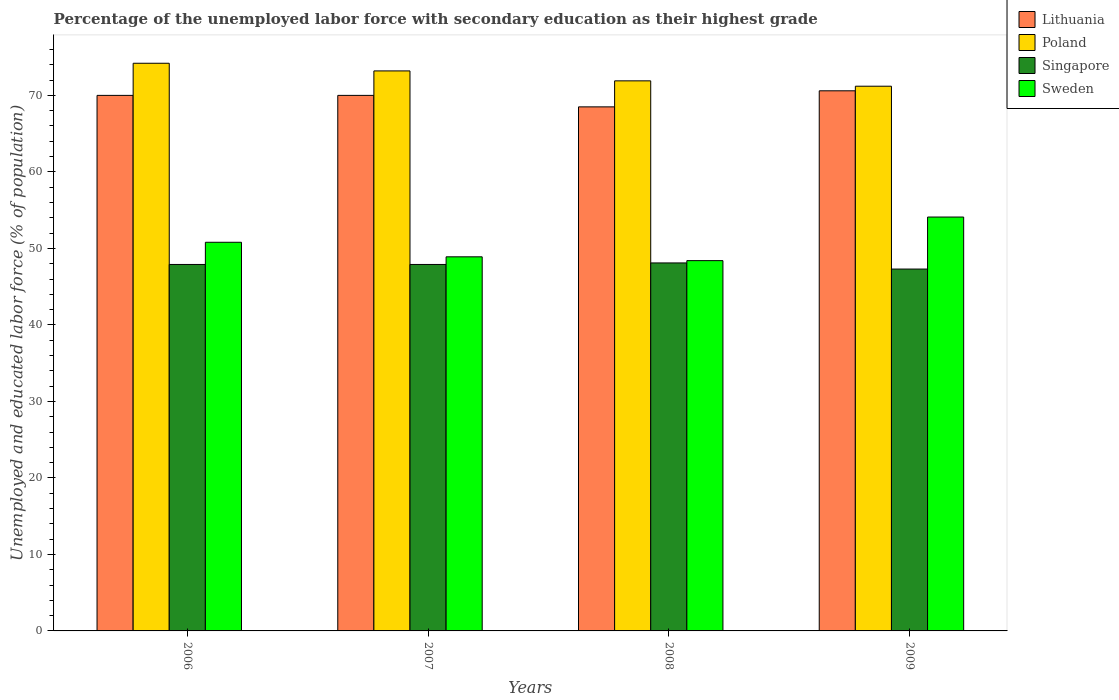Are the number of bars per tick equal to the number of legend labels?
Give a very brief answer. Yes. How many bars are there on the 2nd tick from the left?
Give a very brief answer. 4. How many bars are there on the 3rd tick from the right?
Your response must be concise. 4. What is the label of the 2nd group of bars from the left?
Offer a terse response. 2007. In how many cases, is the number of bars for a given year not equal to the number of legend labels?
Your answer should be compact. 0. What is the percentage of the unemployed labor force with secondary education in Lithuania in 2007?
Give a very brief answer. 70. Across all years, what is the maximum percentage of the unemployed labor force with secondary education in Lithuania?
Give a very brief answer. 70.6. Across all years, what is the minimum percentage of the unemployed labor force with secondary education in Poland?
Give a very brief answer. 71.2. What is the total percentage of the unemployed labor force with secondary education in Sweden in the graph?
Provide a short and direct response. 202.2. What is the difference between the percentage of the unemployed labor force with secondary education in Poland in 2006 and that in 2009?
Ensure brevity in your answer.  3. What is the difference between the percentage of the unemployed labor force with secondary education in Sweden in 2009 and the percentage of the unemployed labor force with secondary education in Lithuania in 2006?
Keep it short and to the point. -15.9. What is the average percentage of the unemployed labor force with secondary education in Poland per year?
Offer a very short reply. 72.62. In the year 2007, what is the difference between the percentage of the unemployed labor force with secondary education in Sweden and percentage of the unemployed labor force with secondary education in Singapore?
Keep it short and to the point. 1. What is the ratio of the percentage of the unemployed labor force with secondary education in Poland in 2007 to that in 2009?
Provide a succinct answer. 1.03. What is the difference between the highest and the second highest percentage of the unemployed labor force with secondary education in Sweden?
Your response must be concise. 3.3. What is the difference between the highest and the lowest percentage of the unemployed labor force with secondary education in Lithuania?
Your response must be concise. 2.1. In how many years, is the percentage of the unemployed labor force with secondary education in Singapore greater than the average percentage of the unemployed labor force with secondary education in Singapore taken over all years?
Give a very brief answer. 3. What does the 4th bar from the right in 2007 represents?
Provide a succinct answer. Lithuania. Is it the case that in every year, the sum of the percentage of the unemployed labor force with secondary education in Sweden and percentage of the unemployed labor force with secondary education in Singapore is greater than the percentage of the unemployed labor force with secondary education in Poland?
Give a very brief answer. Yes. How many bars are there?
Give a very brief answer. 16. Are all the bars in the graph horizontal?
Your answer should be compact. No. How many years are there in the graph?
Keep it short and to the point. 4. Does the graph contain any zero values?
Offer a terse response. No. How many legend labels are there?
Offer a very short reply. 4. How are the legend labels stacked?
Your response must be concise. Vertical. What is the title of the graph?
Provide a succinct answer. Percentage of the unemployed labor force with secondary education as their highest grade. What is the label or title of the Y-axis?
Your answer should be very brief. Unemployed and educated labor force (% of population). What is the Unemployed and educated labor force (% of population) of Lithuania in 2006?
Your answer should be very brief. 70. What is the Unemployed and educated labor force (% of population) of Poland in 2006?
Provide a short and direct response. 74.2. What is the Unemployed and educated labor force (% of population) in Singapore in 2006?
Give a very brief answer. 47.9. What is the Unemployed and educated labor force (% of population) of Sweden in 2006?
Provide a succinct answer. 50.8. What is the Unemployed and educated labor force (% of population) of Poland in 2007?
Make the answer very short. 73.2. What is the Unemployed and educated labor force (% of population) in Singapore in 2007?
Provide a succinct answer. 47.9. What is the Unemployed and educated labor force (% of population) in Sweden in 2007?
Ensure brevity in your answer.  48.9. What is the Unemployed and educated labor force (% of population) in Lithuania in 2008?
Make the answer very short. 68.5. What is the Unemployed and educated labor force (% of population) of Poland in 2008?
Make the answer very short. 71.9. What is the Unemployed and educated labor force (% of population) in Singapore in 2008?
Offer a very short reply. 48.1. What is the Unemployed and educated labor force (% of population) in Sweden in 2008?
Provide a short and direct response. 48.4. What is the Unemployed and educated labor force (% of population) in Lithuania in 2009?
Give a very brief answer. 70.6. What is the Unemployed and educated labor force (% of population) of Poland in 2009?
Make the answer very short. 71.2. What is the Unemployed and educated labor force (% of population) of Singapore in 2009?
Keep it short and to the point. 47.3. What is the Unemployed and educated labor force (% of population) in Sweden in 2009?
Make the answer very short. 54.1. Across all years, what is the maximum Unemployed and educated labor force (% of population) in Lithuania?
Keep it short and to the point. 70.6. Across all years, what is the maximum Unemployed and educated labor force (% of population) in Poland?
Provide a short and direct response. 74.2. Across all years, what is the maximum Unemployed and educated labor force (% of population) in Singapore?
Make the answer very short. 48.1. Across all years, what is the maximum Unemployed and educated labor force (% of population) of Sweden?
Your answer should be very brief. 54.1. Across all years, what is the minimum Unemployed and educated labor force (% of population) in Lithuania?
Provide a short and direct response. 68.5. Across all years, what is the minimum Unemployed and educated labor force (% of population) in Poland?
Ensure brevity in your answer.  71.2. Across all years, what is the minimum Unemployed and educated labor force (% of population) of Singapore?
Your answer should be very brief. 47.3. Across all years, what is the minimum Unemployed and educated labor force (% of population) in Sweden?
Ensure brevity in your answer.  48.4. What is the total Unemployed and educated labor force (% of population) in Lithuania in the graph?
Your response must be concise. 279.1. What is the total Unemployed and educated labor force (% of population) in Poland in the graph?
Offer a very short reply. 290.5. What is the total Unemployed and educated labor force (% of population) of Singapore in the graph?
Your answer should be compact. 191.2. What is the total Unemployed and educated labor force (% of population) of Sweden in the graph?
Provide a short and direct response. 202.2. What is the difference between the Unemployed and educated labor force (% of population) of Lithuania in 2006 and that in 2007?
Offer a very short reply. 0. What is the difference between the Unemployed and educated labor force (% of population) in Poland in 2006 and that in 2007?
Make the answer very short. 1. What is the difference between the Unemployed and educated labor force (% of population) in Singapore in 2006 and that in 2007?
Offer a very short reply. 0. What is the difference between the Unemployed and educated labor force (% of population) in Sweden in 2006 and that in 2008?
Your response must be concise. 2.4. What is the difference between the Unemployed and educated labor force (% of population) of Sweden in 2006 and that in 2009?
Provide a succinct answer. -3.3. What is the difference between the Unemployed and educated labor force (% of population) in Poland in 2007 and that in 2009?
Give a very brief answer. 2. What is the difference between the Unemployed and educated labor force (% of population) in Sweden in 2007 and that in 2009?
Your answer should be very brief. -5.2. What is the difference between the Unemployed and educated labor force (% of population) in Singapore in 2008 and that in 2009?
Keep it short and to the point. 0.8. What is the difference between the Unemployed and educated labor force (% of population) of Sweden in 2008 and that in 2009?
Make the answer very short. -5.7. What is the difference between the Unemployed and educated labor force (% of population) in Lithuania in 2006 and the Unemployed and educated labor force (% of population) in Singapore in 2007?
Your answer should be compact. 22.1. What is the difference between the Unemployed and educated labor force (% of population) of Lithuania in 2006 and the Unemployed and educated labor force (% of population) of Sweden in 2007?
Your answer should be very brief. 21.1. What is the difference between the Unemployed and educated labor force (% of population) of Poland in 2006 and the Unemployed and educated labor force (% of population) of Singapore in 2007?
Your answer should be compact. 26.3. What is the difference between the Unemployed and educated labor force (% of population) of Poland in 2006 and the Unemployed and educated labor force (% of population) of Sweden in 2007?
Give a very brief answer. 25.3. What is the difference between the Unemployed and educated labor force (% of population) in Singapore in 2006 and the Unemployed and educated labor force (% of population) in Sweden in 2007?
Make the answer very short. -1. What is the difference between the Unemployed and educated labor force (% of population) in Lithuania in 2006 and the Unemployed and educated labor force (% of population) in Poland in 2008?
Your answer should be very brief. -1.9. What is the difference between the Unemployed and educated labor force (% of population) of Lithuania in 2006 and the Unemployed and educated labor force (% of population) of Singapore in 2008?
Give a very brief answer. 21.9. What is the difference between the Unemployed and educated labor force (% of population) of Lithuania in 2006 and the Unemployed and educated labor force (% of population) of Sweden in 2008?
Give a very brief answer. 21.6. What is the difference between the Unemployed and educated labor force (% of population) of Poland in 2006 and the Unemployed and educated labor force (% of population) of Singapore in 2008?
Keep it short and to the point. 26.1. What is the difference between the Unemployed and educated labor force (% of population) in Poland in 2006 and the Unemployed and educated labor force (% of population) in Sweden in 2008?
Give a very brief answer. 25.8. What is the difference between the Unemployed and educated labor force (% of population) in Singapore in 2006 and the Unemployed and educated labor force (% of population) in Sweden in 2008?
Provide a succinct answer. -0.5. What is the difference between the Unemployed and educated labor force (% of population) in Lithuania in 2006 and the Unemployed and educated labor force (% of population) in Singapore in 2009?
Make the answer very short. 22.7. What is the difference between the Unemployed and educated labor force (% of population) of Poland in 2006 and the Unemployed and educated labor force (% of population) of Singapore in 2009?
Keep it short and to the point. 26.9. What is the difference between the Unemployed and educated labor force (% of population) in Poland in 2006 and the Unemployed and educated labor force (% of population) in Sweden in 2009?
Offer a terse response. 20.1. What is the difference between the Unemployed and educated labor force (% of population) in Singapore in 2006 and the Unemployed and educated labor force (% of population) in Sweden in 2009?
Your answer should be compact. -6.2. What is the difference between the Unemployed and educated labor force (% of population) of Lithuania in 2007 and the Unemployed and educated labor force (% of population) of Poland in 2008?
Your response must be concise. -1.9. What is the difference between the Unemployed and educated labor force (% of population) in Lithuania in 2007 and the Unemployed and educated labor force (% of population) in Singapore in 2008?
Provide a short and direct response. 21.9. What is the difference between the Unemployed and educated labor force (% of population) in Lithuania in 2007 and the Unemployed and educated labor force (% of population) in Sweden in 2008?
Keep it short and to the point. 21.6. What is the difference between the Unemployed and educated labor force (% of population) in Poland in 2007 and the Unemployed and educated labor force (% of population) in Singapore in 2008?
Your response must be concise. 25.1. What is the difference between the Unemployed and educated labor force (% of population) in Poland in 2007 and the Unemployed and educated labor force (% of population) in Sweden in 2008?
Keep it short and to the point. 24.8. What is the difference between the Unemployed and educated labor force (% of population) in Lithuania in 2007 and the Unemployed and educated labor force (% of population) in Poland in 2009?
Ensure brevity in your answer.  -1.2. What is the difference between the Unemployed and educated labor force (% of population) of Lithuania in 2007 and the Unemployed and educated labor force (% of population) of Singapore in 2009?
Provide a succinct answer. 22.7. What is the difference between the Unemployed and educated labor force (% of population) in Lithuania in 2007 and the Unemployed and educated labor force (% of population) in Sweden in 2009?
Make the answer very short. 15.9. What is the difference between the Unemployed and educated labor force (% of population) in Poland in 2007 and the Unemployed and educated labor force (% of population) in Singapore in 2009?
Provide a succinct answer. 25.9. What is the difference between the Unemployed and educated labor force (% of population) in Poland in 2007 and the Unemployed and educated labor force (% of population) in Sweden in 2009?
Ensure brevity in your answer.  19.1. What is the difference between the Unemployed and educated labor force (% of population) in Singapore in 2007 and the Unemployed and educated labor force (% of population) in Sweden in 2009?
Keep it short and to the point. -6.2. What is the difference between the Unemployed and educated labor force (% of population) in Lithuania in 2008 and the Unemployed and educated labor force (% of population) in Singapore in 2009?
Offer a terse response. 21.2. What is the difference between the Unemployed and educated labor force (% of population) in Poland in 2008 and the Unemployed and educated labor force (% of population) in Singapore in 2009?
Give a very brief answer. 24.6. What is the difference between the Unemployed and educated labor force (% of population) in Poland in 2008 and the Unemployed and educated labor force (% of population) in Sweden in 2009?
Offer a terse response. 17.8. What is the average Unemployed and educated labor force (% of population) of Lithuania per year?
Give a very brief answer. 69.78. What is the average Unemployed and educated labor force (% of population) in Poland per year?
Your answer should be compact. 72.62. What is the average Unemployed and educated labor force (% of population) in Singapore per year?
Offer a terse response. 47.8. What is the average Unemployed and educated labor force (% of population) in Sweden per year?
Offer a terse response. 50.55. In the year 2006, what is the difference between the Unemployed and educated labor force (% of population) in Lithuania and Unemployed and educated labor force (% of population) in Singapore?
Make the answer very short. 22.1. In the year 2006, what is the difference between the Unemployed and educated labor force (% of population) in Lithuania and Unemployed and educated labor force (% of population) in Sweden?
Make the answer very short. 19.2. In the year 2006, what is the difference between the Unemployed and educated labor force (% of population) in Poland and Unemployed and educated labor force (% of population) in Singapore?
Keep it short and to the point. 26.3. In the year 2006, what is the difference between the Unemployed and educated labor force (% of population) in Poland and Unemployed and educated labor force (% of population) in Sweden?
Your answer should be very brief. 23.4. In the year 2007, what is the difference between the Unemployed and educated labor force (% of population) of Lithuania and Unemployed and educated labor force (% of population) of Poland?
Give a very brief answer. -3.2. In the year 2007, what is the difference between the Unemployed and educated labor force (% of population) in Lithuania and Unemployed and educated labor force (% of population) in Singapore?
Your answer should be compact. 22.1. In the year 2007, what is the difference between the Unemployed and educated labor force (% of population) in Lithuania and Unemployed and educated labor force (% of population) in Sweden?
Keep it short and to the point. 21.1. In the year 2007, what is the difference between the Unemployed and educated labor force (% of population) in Poland and Unemployed and educated labor force (% of population) in Singapore?
Give a very brief answer. 25.3. In the year 2007, what is the difference between the Unemployed and educated labor force (% of population) of Poland and Unemployed and educated labor force (% of population) of Sweden?
Keep it short and to the point. 24.3. In the year 2008, what is the difference between the Unemployed and educated labor force (% of population) in Lithuania and Unemployed and educated labor force (% of population) in Singapore?
Provide a succinct answer. 20.4. In the year 2008, what is the difference between the Unemployed and educated labor force (% of population) in Lithuania and Unemployed and educated labor force (% of population) in Sweden?
Your answer should be very brief. 20.1. In the year 2008, what is the difference between the Unemployed and educated labor force (% of population) of Poland and Unemployed and educated labor force (% of population) of Singapore?
Your answer should be very brief. 23.8. In the year 2009, what is the difference between the Unemployed and educated labor force (% of population) in Lithuania and Unemployed and educated labor force (% of population) in Poland?
Make the answer very short. -0.6. In the year 2009, what is the difference between the Unemployed and educated labor force (% of population) in Lithuania and Unemployed and educated labor force (% of population) in Singapore?
Your answer should be very brief. 23.3. In the year 2009, what is the difference between the Unemployed and educated labor force (% of population) in Lithuania and Unemployed and educated labor force (% of population) in Sweden?
Offer a very short reply. 16.5. In the year 2009, what is the difference between the Unemployed and educated labor force (% of population) of Poland and Unemployed and educated labor force (% of population) of Singapore?
Your answer should be compact. 23.9. In the year 2009, what is the difference between the Unemployed and educated labor force (% of population) of Poland and Unemployed and educated labor force (% of population) of Sweden?
Your answer should be compact. 17.1. What is the ratio of the Unemployed and educated labor force (% of population) of Poland in 2006 to that in 2007?
Give a very brief answer. 1.01. What is the ratio of the Unemployed and educated labor force (% of population) in Sweden in 2006 to that in 2007?
Provide a succinct answer. 1.04. What is the ratio of the Unemployed and educated labor force (% of population) in Lithuania in 2006 to that in 2008?
Offer a very short reply. 1.02. What is the ratio of the Unemployed and educated labor force (% of population) in Poland in 2006 to that in 2008?
Offer a terse response. 1.03. What is the ratio of the Unemployed and educated labor force (% of population) in Singapore in 2006 to that in 2008?
Ensure brevity in your answer.  1. What is the ratio of the Unemployed and educated labor force (% of population) in Sweden in 2006 to that in 2008?
Your response must be concise. 1.05. What is the ratio of the Unemployed and educated labor force (% of population) in Poland in 2006 to that in 2009?
Give a very brief answer. 1.04. What is the ratio of the Unemployed and educated labor force (% of population) in Singapore in 2006 to that in 2009?
Give a very brief answer. 1.01. What is the ratio of the Unemployed and educated labor force (% of population) in Sweden in 2006 to that in 2009?
Ensure brevity in your answer.  0.94. What is the ratio of the Unemployed and educated labor force (% of population) in Lithuania in 2007 to that in 2008?
Your answer should be very brief. 1.02. What is the ratio of the Unemployed and educated labor force (% of population) of Poland in 2007 to that in 2008?
Your answer should be very brief. 1.02. What is the ratio of the Unemployed and educated labor force (% of population) in Singapore in 2007 to that in 2008?
Give a very brief answer. 1. What is the ratio of the Unemployed and educated labor force (% of population) of Sweden in 2007 to that in 2008?
Give a very brief answer. 1.01. What is the ratio of the Unemployed and educated labor force (% of population) of Poland in 2007 to that in 2009?
Ensure brevity in your answer.  1.03. What is the ratio of the Unemployed and educated labor force (% of population) of Singapore in 2007 to that in 2009?
Offer a terse response. 1.01. What is the ratio of the Unemployed and educated labor force (% of population) in Sweden in 2007 to that in 2009?
Provide a succinct answer. 0.9. What is the ratio of the Unemployed and educated labor force (% of population) in Lithuania in 2008 to that in 2009?
Offer a terse response. 0.97. What is the ratio of the Unemployed and educated labor force (% of population) in Poland in 2008 to that in 2009?
Your answer should be compact. 1.01. What is the ratio of the Unemployed and educated labor force (% of population) in Singapore in 2008 to that in 2009?
Provide a succinct answer. 1.02. What is the ratio of the Unemployed and educated labor force (% of population) of Sweden in 2008 to that in 2009?
Ensure brevity in your answer.  0.89. What is the difference between the highest and the second highest Unemployed and educated labor force (% of population) of Sweden?
Provide a short and direct response. 3.3. What is the difference between the highest and the lowest Unemployed and educated labor force (% of population) in Poland?
Provide a short and direct response. 3. What is the difference between the highest and the lowest Unemployed and educated labor force (% of population) of Singapore?
Offer a terse response. 0.8. 